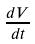<formula> <loc_0><loc_0><loc_500><loc_500>\frac { d V } { d t }</formula> 